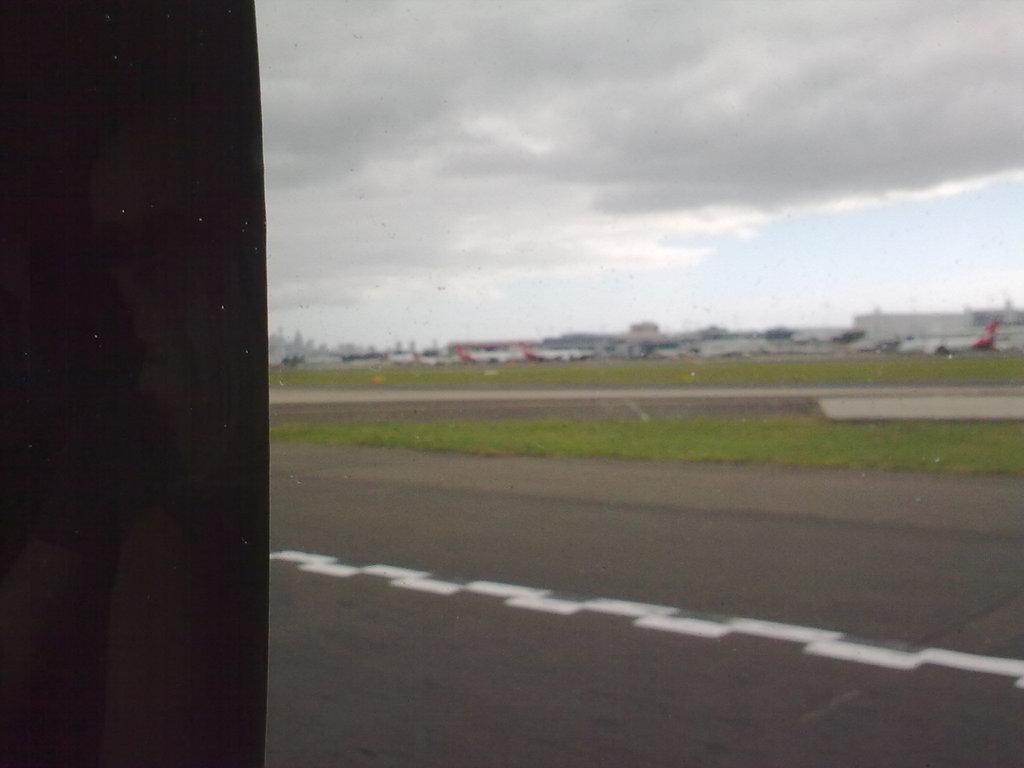Please provide a concise description of this image. In this picture we can see the buildings, aeroplanes, poles, trees, grass. At the bottom of the image we can see the ground. On the left side of the image we can see the black color. At the top of the image we can see the clouds are present in the sky. 